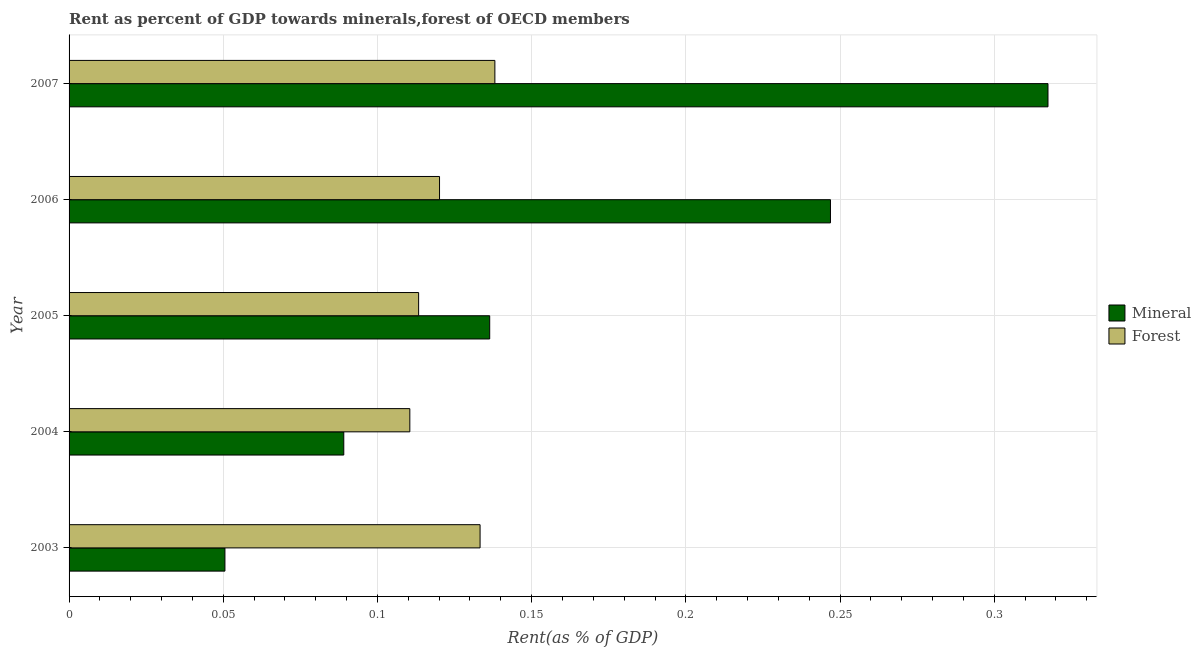How many different coloured bars are there?
Your answer should be very brief. 2. Are the number of bars per tick equal to the number of legend labels?
Offer a very short reply. Yes. Are the number of bars on each tick of the Y-axis equal?
Offer a terse response. Yes. How many bars are there on the 5th tick from the bottom?
Keep it short and to the point. 2. What is the mineral rent in 2007?
Keep it short and to the point. 0.32. Across all years, what is the maximum forest rent?
Offer a very short reply. 0.14. Across all years, what is the minimum forest rent?
Give a very brief answer. 0.11. In which year was the forest rent maximum?
Make the answer very short. 2007. What is the total forest rent in the graph?
Offer a very short reply. 0.62. What is the difference between the mineral rent in 2005 and that in 2006?
Give a very brief answer. -0.11. What is the difference between the forest rent in 2004 and the mineral rent in 2003?
Your answer should be compact. 0.06. What is the average mineral rent per year?
Make the answer very short. 0.17. In the year 2004, what is the difference between the mineral rent and forest rent?
Offer a very short reply. -0.02. In how many years, is the mineral rent greater than 0.12000000000000001 %?
Give a very brief answer. 3. What is the ratio of the mineral rent in 2005 to that in 2007?
Offer a terse response. 0.43. Is the forest rent in 2003 less than that in 2007?
Offer a terse response. Yes. Is the difference between the forest rent in 2005 and 2007 greater than the difference between the mineral rent in 2005 and 2007?
Your answer should be very brief. Yes. What is the difference between the highest and the second highest forest rent?
Provide a succinct answer. 0.01. In how many years, is the forest rent greater than the average forest rent taken over all years?
Give a very brief answer. 2. What does the 1st bar from the top in 2005 represents?
Give a very brief answer. Forest. What does the 2nd bar from the bottom in 2007 represents?
Offer a terse response. Forest. Are all the bars in the graph horizontal?
Your answer should be compact. Yes. How many years are there in the graph?
Your answer should be very brief. 5. Are the values on the major ticks of X-axis written in scientific E-notation?
Provide a succinct answer. No. Where does the legend appear in the graph?
Offer a terse response. Center right. How are the legend labels stacked?
Provide a short and direct response. Vertical. What is the title of the graph?
Your answer should be compact. Rent as percent of GDP towards minerals,forest of OECD members. What is the label or title of the X-axis?
Give a very brief answer. Rent(as % of GDP). What is the label or title of the Y-axis?
Your answer should be very brief. Year. What is the Rent(as % of GDP) of Mineral in 2003?
Make the answer very short. 0.05. What is the Rent(as % of GDP) of Forest in 2003?
Provide a succinct answer. 0.13. What is the Rent(as % of GDP) in Mineral in 2004?
Keep it short and to the point. 0.09. What is the Rent(as % of GDP) of Forest in 2004?
Your answer should be very brief. 0.11. What is the Rent(as % of GDP) in Mineral in 2005?
Your answer should be compact. 0.14. What is the Rent(as % of GDP) of Forest in 2005?
Offer a very short reply. 0.11. What is the Rent(as % of GDP) in Mineral in 2006?
Your answer should be very brief. 0.25. What is the Rent(as % of GDP) in Forest in 2006?
Keep it short and to the point. 0.12. What is the Rent(as % of GDP) in Mineral in 2007?
Offer a terse response. 0.32. What is the Rent(as % of GDP) of Forest in 2007?
Give a very brief answer. 0.14. Across all years, what is the maximum Rent(as % of GDP) of Mineral?
Make the answer very short. 0.32. Across all years, what is the maximum Rent(as % of GDP) of Forest?
Provide a succinct answer. 0.14. Across all years, what is the minimum Rent(as % of GDP) in Mineral?
Keep it short and to the point. 0.05. Across all years, what is the minimum Rent(as % of GDP) of Forest?
Make the answer very short. 0.11. What is the total Rent(as % of GDP) of Mineral in the graph?
Provide a short and direct response. 0.84. What is the total Rent(as % of GDP) of Forest in the graph?
Your response must be concise. 0.62. What is the difference between the Rent(as % of GDP) in Mineral in 2003 and that in 2004?
Provide a short and direct response. -0.04. What is the difference between the Rent(as % of GDP) of Forest in 2003 and that in 2004?
Give a very brief answer. 0.02. What is the difference between the Rent(as % of GDP) in Mineral in 2003 and that in 2005?
Offer a very short reply. -0.09. What is the difference between the Rent(as % of GDP) of Forest in 2003 and that in 2005?
Provide a succinct answer. 0.02. What is the difference between the Rent(as % of GDP) of Mineral in 2003 and that in 2006?
Give a very brief answer. -0.2. What is the difference between the Rent(as % of GDP) of Forest in 2003 and that in 2006?
Keep it short and to the point. 0.01. What is the difference between the Rent(as % of GDP) in Mineral in 2003 and that in 2007?
Make the answer very short. -0.27. What is the difference between the Rent(as % of GDP) in Forest in 2003 and that in 2007?
Provide a succinct answer. -0. What is the difference between the Rent(as % of GDP) of Mineral in 2004 and that in 2005?
Provide a short and direct response. -0.05. What is the difference between the Rent(as % of GDP) in Forest in 2004 and that in 2005?
Keep it short and to the point. -0. What is the difference between the Rent(as % of GDP) of Mineral in 2004 and that in 2006?
Provide a succinct answer. -0.16. What is the difference between the Rent(as % of GDP) of Forest in 2004 and that in 2006?
Provide a short and direct response. -0.01. What is the difference between the Rent(as % of GDP) in Mineral in 2004 and that in 2007?
Provide a short and direct response. -0.23. What is the difference between the Rent(as % of GDP) of Forest in 2004 and that in 2007?
Offer a very short reply. -0.03. What is the difference between the Rent(as % of GDP) of Mineral in 2005 and that in 2006?
Offer a very short reply. -0.11. What is the difference between the Rent(as % of GDP) of Forest in 2005 and that in 2006?
Your response must be concise. -0.01. What is the difference between the Rent(as % of GDP) of Mineral in 2005 and that in 2007?
Offer a terse response. -0.18. What is the difference between the Rent(as % of GDP) in Forest in 2005 and that in 2007?
Your answer should be very brief. -0.02. What is the difference between the Rent(as % of GDP) in Mineral in 2006 and that in 2007?
Make the answer very short. -0.07. What is the difference between the Rent(as % of GDP) of Forest in 2006 and that in 2007?
Your answer should be very brief. -0.02. What is the difference between the Rent(as % of GDP) in Mineral in 2003 and the Rent(as % of GDP) in Forest in 2004?
Keep it short and to the point. -0.06. What is the difference between the Rent(as % of GDP) of Mineral in 2003 and the Rent(as % of GDP) of Forest in 2005?
Offer a terse response. -0.06. What is the difference between the Rent(as % of GDP) in Mineral in 2003 and the Rent(as % of GDP) in Forest in 2006?
Your response must be concise. -0.07. What is the difference between the Rent(as % of GDP) of Mineral in 2003 and the Rent(as % of GDP) of Forest in 2007?
Offer a very short reply. -0.09. What is the difference between the Rent(as % of GDP) in Mineral in 2004 and the Rent(as % of GDP) in Forest in 2005?
Your answer should be compact. -0.02. What is the difference between the Rent(as % of GDP) of Mineral in 2004 and the Rent(as % of GDP) of Forest in 2006?
Make the answer very short. -0.03. What is the difference between the Rent(as % of GDP) of Mineral in 2004 and the Rent(as % of GDP) of Forest in 2007?
Offer a very short reply. -0.05. What is the difference between the Rent(as % of GDP) of Mineral in 2005 and the Rent(as % of GDP) of Forest in 2006?
Your answer should be compact. 0.02. What is the difference between the Rent(as % of GDP) of Mineral in 2005 and the Rent(as % of GDP) of Forest in 2007?
Offer a very short reply. -0. What is the difference between the Rent(as % of GDP) in Mineral in 2006 and the Rent(as % of GDP) in Forest in 2007?
Give a very brief answer. 0.11. What is the average Rent(as % of GDP) of Mineral per year?
Provide a short and direct response. 0.17. What is the average Rent(as % of GDP) of Forest per year?
Your response must be concise. 0.12. In the year 2003, what is the difference between the Rent(as % of GDP) in Mineral and Rent(as % of GDP) in Forest?
Ensure brevity in your answer.  -0.08. In the year 2004, what is the difference between the Rent(as % of GDP) in Mineral and Rent(as % of GDP) in Forest?
Your answer should be compact. -0.02. In the year 2005, what is the difference between the Rent(as % of GDP) of Mineral and Rent(as % of GDP) of Forest?
Offer a terse response. 0.02. In the year 2006, what is the difference between the Rent(as % of GDP) in Mineral and Rent(as % of GDP) in Forest?
Your answer should be compact. 0.13. In the year 2007, what is the difference between the Rent(as % of GDP) in Mineral and Rent(as % of GDP) in Forest?
Your answer should be compact. 0.18. What is the ratio of the Rent(as % of GDP) in Mineral in 2003 to that in 2004?
Make the answer very short. 0.57. What is the ratio of the Rent(as % of GDP) in Forest in 2003 to that in 2004?
Offer a very short reply. 1.21. What is the ratio of the Rent(as % of GDP) of Mineral in 2003 to that in 2005?
Offer a very short reply. 0.37. What is the ratio of the Rent(as % of GDP) of Forest in 2003 to that in 2005?
Your answer should be very brief. 1.18. What is the ratio of the Rent(as % of GDP) of Mineral in 2003 to that in 2006?
Provide a short and direct response. 0.2. What is the ratio of the Rent(as % of GDP) in Forest in 2003 to that in 2006?
Provide a short and direct response. 1.11. What is the ratio of the Rent(as % of GDP) of Mineral in 2003 to that in 2007?
Your answer should be very brief. 0.16. What is the ratio of the Rent(as % of GDP) of Forest in 2003 to that in 2007?
Keep it short and to the point. 0.97. What is the ratio of the Rent(as % of GDP) in Mineral in 2004 to that in 2005?
Provide a short and direct response. 0.65. What is the ratio of the Rent(as % of GDP) of Forest in 2004 to that in 2005?
Ensure brevity in your answer.  0.97. What is the ratio of the Rent(as % of GDP) of Mineral in 2004 to that in 2006?
Provide a short and direct response. 0.36. What is the ratio of the Rent(as % of GDP) in Forest in 2004 to that in 2006?
Your answer should be very brief. 0.92. What is the ratio of the Rent(as % of GDP) of Mineral in 2004 to that in 2007?
Your answer should be compact. 0.28. What is the ratio of the Rent(as % of GDP) of Forest in 2004 to that in 2007?
Offer a very short reply. 0.8. What is the ratio of the Rent(as % of GDP) of Mineral in 2005 to that in 2006?
Your response must be concise. 0.55. What is the ratio of the Rent(as % of GDP) in Forest in 2005 to that in 2006?
Offer a terse response. 0.94. What is the ratio of the Rent(as % of GDP) in Mineral in 2005 to that in 2007?
Provide a succinct answer. 0.43. What is the ratio of the Rent(as % of GDP) in Forest in 2005 to that in 2007?
Your response must be concise. 0.82. What is the ratio of the Rent(as % of GDP) in Forest in 2006 to that in 2007?
Keep it short and to the point. 0.87. What is the difference between the highest and the second highest Rent(as % of GDP) in Mineral?
Give a very brief answer. 0.07. What is the difference between the highest and the second highest Rent(as % of GDP) in Forest?
Provide a short and direct response. 0. What is the difference between the highest and the lowest Rent(as % of GDP) in Mineral?
Provide a succinct answer. 0.27. What is the difference between the highest and the lowest Rent(as % of GDP) of Forest?
Your response must be concise. 0.03. 